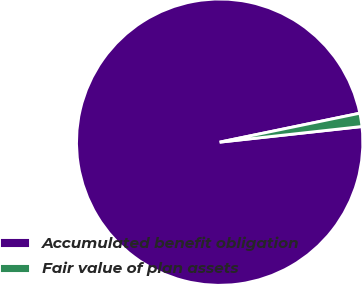<chart> <loc_0><loc_0><loc_500><loc_500><pie_chart><fcel>Accumulated benefit obligation<fcel>Fair value of plan assets<nl><fcel>98.5%<fcel>1.5%<nl></chart> 